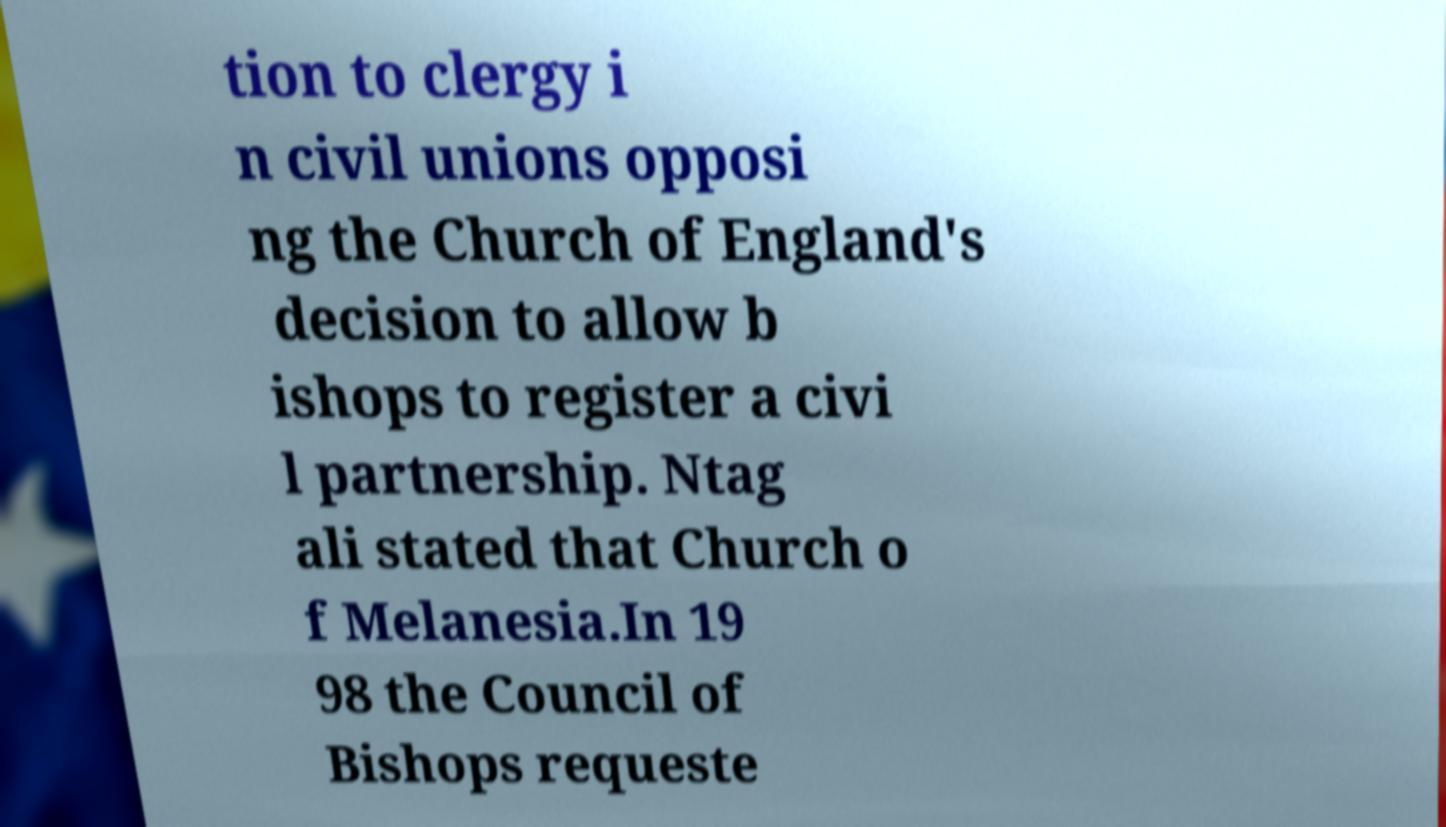For documentation purposes, I need the text within this image transcribed. Could you provide that? tion to clergy i n civil unions opposi ng the Church of England's decision to allow b ishops to register a civi l partnership. Ntag ali stated that Church o f Melanesia.In 19 98 the Council of Bishops requeste 